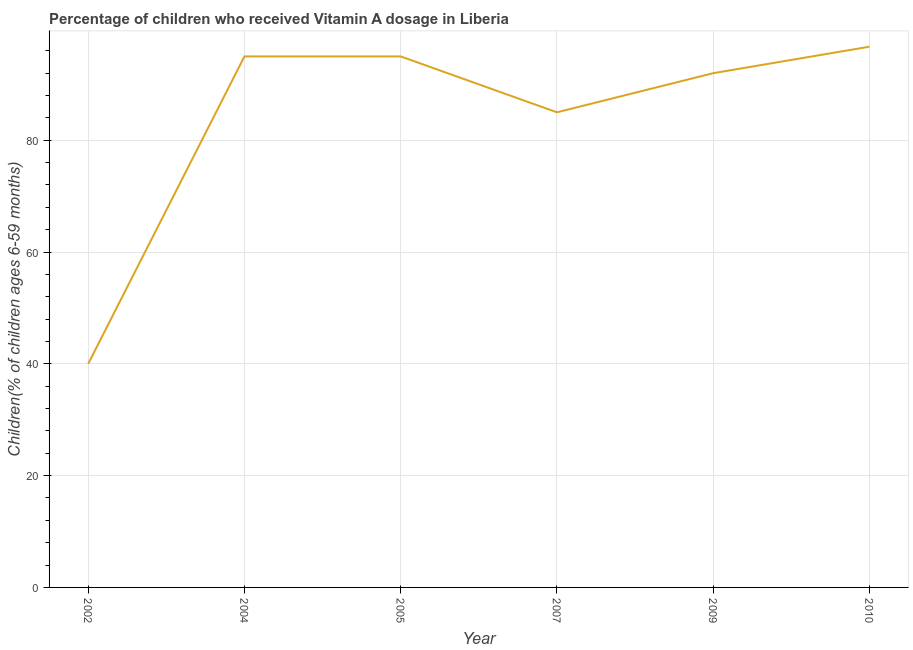What is the vitamin a supplementation coverage rate in 2009?
Ensure brevity in your answer.  92. Across all years, what is the maximum vitamin a supplementation coverage rate?
Keep it short and to the point. 96.74. Across all years, what is the minimum vitamin a supplementation coverage rate?
Your response must be concise. 40. In which year was the vitamin a supplementation coverage rate minimum?
Your response must be concise. 2002. What is the sum of the vitamin a supplementation coverage rate?
Your response must be concise. 503.74. What is the difference between the vitamin a supplementation coverage rate in 2005 and 2010?
Offer a very short reply. -1.74. What is the average vitamin a supplementation coverage rate per year?
Your answer should be compact. 83.96. What is the median vitamin a supplementation coverage rate?
Your answer should be very brief. 93.5. In how many years, is the vitamin a supplementation coverage rate greater than 76 %?
Offer a terse response. 5. Do a majority of the years between 2009 and 2007 (inclusive) have vitamin a supplementation coverage rate greater than 40 %?
Your answer should be very brief. No. What is the ratio of the vitamin a supplementation coverage rate in 2005 to that in 2007?
Your answer should be very brief. 1.12. What is the difference between the highest and the second highest vitamin a supplementation coverage rate?
Provide a succinct answer. 1.74. Is the sum of the vitamin a supplementation coverage rate in 2005 and 2009 greater than the maximum vitamin a supplementation coverage rate across all years?
Keep it short and to the point. Yes. What is the difference between the highest and the lowest vitamin a supplementation coverage rate?
Give a very brief answer. 56.74. In how many years, is the vitamin a supplementation coverage rate greater than the average vitamin a supplementation coverage rate taken over all years?
Keep it short and to the point. 5. How many lines are there?
Offer a terse response. 1. Are the values on the major ticks of Y-axis written in scientific E-notation?
Offer a terse response. No. What is the title of the graph?
Offer a very short reply. Percentage of children who received Vitamin A dosage in Liberia. What is the label or title of the X-axis?
Provide a succinct answer. Year. What is the label or title of the Y-axis?
Provide a succinct answer. Children(% of children ages 6-59 months). What is the Children(% of children ages 6-59 months) of 2004?
Give a very brief answer. 95. What is the Children(% of children ages 6-59 months) in 2005?
Keep it short and to the point. 95. What is the Children(% of children ages 6-59 months) in 2009?
Give a very brief answer. 92. What is the Children(% of children ages 6-59 months) in 2010?
Provide a succinct answer. 96.74. What is the difference between the Children(% of children ages 6-59 months) in 2002 and 2004?
Offer a very short reply. -55. What is the difference between the Children(% of children ages 6-59 months) in 2002 and 2005?
Your answer should be very brief. -55. What is the difference between the Children(% of children ages 6-59 months) in 2002 and 2007?
Ensure brevity in your answer.  -45. What is the difference between the Children(% of children ages 6-59 months) in 2002 and 2009?
Your answer should be compact. -52. What is the difference between the Children(% of children ages 6-59 months) in 2002 and 2010?
Your answer should be compact. -56.74. What is the difference between the Children(% of children ages 6-59 months) in 2004 and 2007?
Make the answer very short. 10. What is the difference between the Children(% of children ages 6-59 months) in 2004 and 2009?
Provide a succinct answer. 3. What is the difference between the Children(% of children ages 6-59 months) in 2004 and 2010?
Ensure brevity in your answer.  -1.74. What is the difference between the Children(% of children ages 6-59 months) in 2005 and 2009?
Offer a very short reply. 3. What is the difference between the Children(% of children ages 6-59 months) in 2005 and 2010?
Make the answer very short. -1.74. What is the difference between the Children(% of children ages 6-59 months) in 2007 and 2009?
Offer a terse response. -7. What is the difference between the Children(% of children ages 6-59 months) in 2007 and 2010?
Provide a short and direct response. -11.74. What is the difference between the Children(% of children ages 6-59 months) in 2009 and 2010?
Your answer should be compact. -4.74. What is the ratio of the Children(% of children ages 6-59 months) in 2002 to that in 2004?
Offer a very short reply. 0.42. What is the ratio of the Children(% of children ages 6-59 months) in 2002 to that in 2005?
Provide a short and direct response. 0.42. What is the ratio of the Children(% of children ages 6-59 months) in 2002 to that in 2007?
Keep it short and to the point. 0.47. What is the ratio of the Children(% of children ages 6-59 months) in 2002 to that in 2009?
Offer a terse response. 0.43. What is the ratio of the Children(% of children ages 6-59 months) in 2002 to that in 2010?
Give a very brief answer. 0.41. What is the ratio of the Children(% of children ages 6-59 months) in 2004 to that in 2005?
Your answer should be very brief. 1. What is the ratio of the Children(% of children ages 6-59 months) in 2004 to that in 2007?
Provide a short and direct response. 1.12. What is the ratio of the Children(% of children ages 6-59 months) in 2004 to that in 2009?
Your answer should be very brief. 1.03. What is the ratio of the Children(% of children ages 6-59 months) in 2004 to that in 2010?
Give a very brief answer. 0.98. What is the ratio of the Children(% of children ages 6-59 months) in 2005 to that in 2007?
Your response must be concise. 1.12. What is the ratio of the Children(% of children ages 6-59 months) in 2005 to that in 2009?
Your answer should be very brief. 1.03. What is the ratio of the Children(% of children ages 6-59 months) in 2005 to that in 2010?
Give a very brief answer. 0.98. What is the ratio of the Children(% of children ages 6-59 months) in 2007 to that in 2009?
Offer a terse response. 0.92. What is the ratio of the Children(% of children ages 6-59 months) in 2007 to that in 2010?
Provide a succinct answer. 0.88. What is the ratio of the Children(% of children ages 6-59 months) in 2009 to that in 2010?
Your answer should be compact. 0.95. 